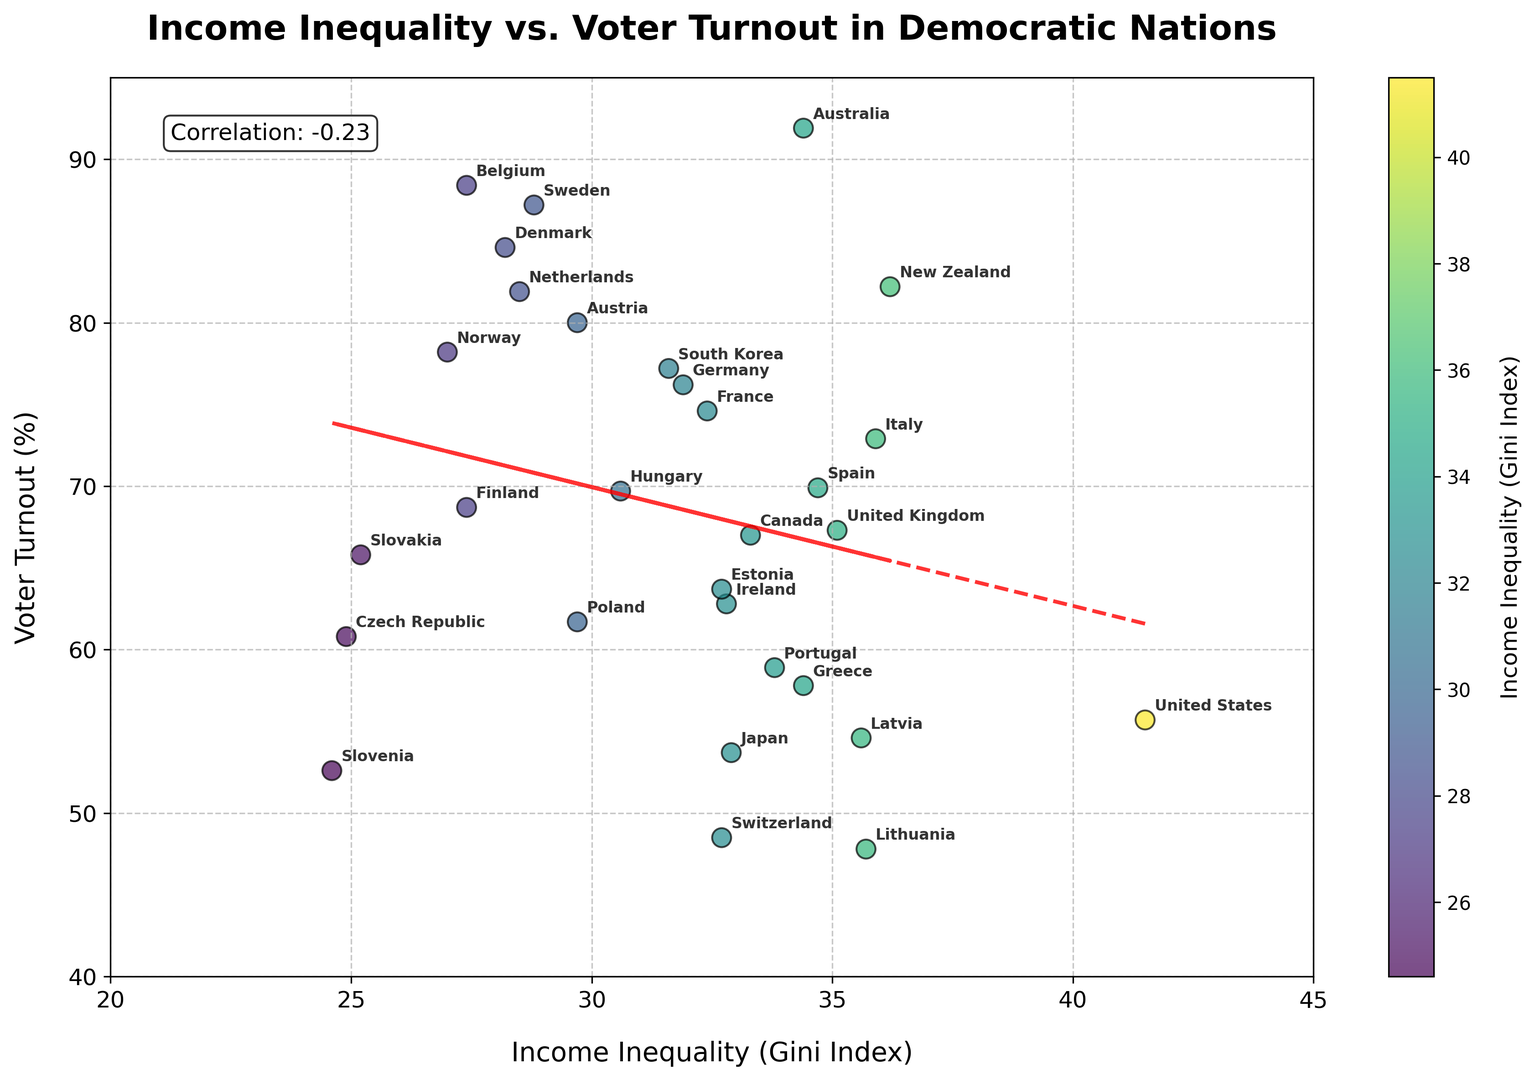What is the correlation between income inequality and voter turnout? The correlation coefficient is provided in the text box within the scatter plot. It is displayed as a numerical value which indicates the strength and direction of the relationship between the two variables.
Answer: -0.36 Which country has the highest voter turnout? By examining the y-axis, which represents voter turnout percentage, the country with the highest plot point on this axis will have the highest voter turnout. According to the figure, Australia has the highest voter turnout.
Answer: Australia Which country has the lowest income inequality? By looking at the x-axis, which represents the Gini Index (income inequality), the country with the lowest plot point on this axis will have the lowest income inequality. From the figure, Slovenia has the lowest income inequality.
Answer: Slovenia What is the trendline equation between income inequality and voter turnout? The equation of the trendline is visible on the plot. It is determined by fitting a linear model to the data points, represented as \( y = mx + c \), where \(m\) is the slope and \(c\) is the intercept. The equation shown in the plot is approximately \( y = -0.7885x + 91.2137 \).
Answer: y = -0.79x + 91.21 Do countries with lower Gini Index tend to have higher voter turnout? By observing the scatter plot and the trendline, we can infer that countries with lower Gini Index (left side of the x-axis) tend to be higher on the y-axis (voter turnout), suggesting that lower income inequality is generally associated with higher voter turnout. The negative correlation coefficient also supports this observation.
Answer: Yes Which region has a tighter cluster of countries in terms of income inequality and voter turnout? By visually examining the scatter plot, observe the clusters of points and identify where they are more densely packed. One area of tight clustering can be observed towards the lower left of the plot, around Gini Index values from 24 to 29 and voter turnout from 60% to 90%. Scandinavian countries like Denmark, Norway, and Finland fall in this range.
Answer: Scandinavia (e.g., Denmark, Norway, Finland) How does voter turnout in the United States compare to Sweden? Locate the data points representing the United States and Sweden on the scatter plot. The United States has a voter turnout of 55.7% while Sweden has a turnout of 87.2%. Hence, Sweden has a significantly higher voter turnout compared to the United States.
Answer: Sweden has a much higher voter turnout Are there any outlier countries in terms of voter turnout? If so, name one. Outliers are points that stand far apart from the rest of the data. Observing the scatter plot, Australia has a markedly high voter turnout (91.9%) compared to other countries with similar or different Gini Index values, making it an outlier.
Answer: Australia What can you say about the voter turnout in countries with Gini Index around 32? Locate the points around the Gini Index value of 32 on the x-axis and observe their y-values. Countries around this Gini Index value exhibit a wide range of voter turnout percentages, such as Germany (~76.2%), Ireland (~62.8%), and Switzerland (~48.5%). Hence, there is no consistent trend in this range.
Answer: Wide range in voter turnout, no consistent trend 